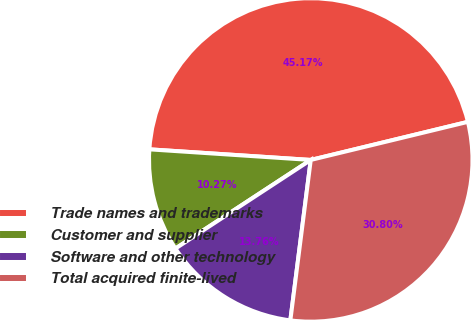<chart> <loc_0><loc_0><loc_500><loc_500><pie_chart><fcel>Trade names and trademarks<fcel>Customer and supplier<fcel>Software and other technology<fcel>Total acquired finite-lived<nl><fcel>45.17%<fcel>10.27%<fcel>13.76%<fcel>30.8%<nl></chart> 